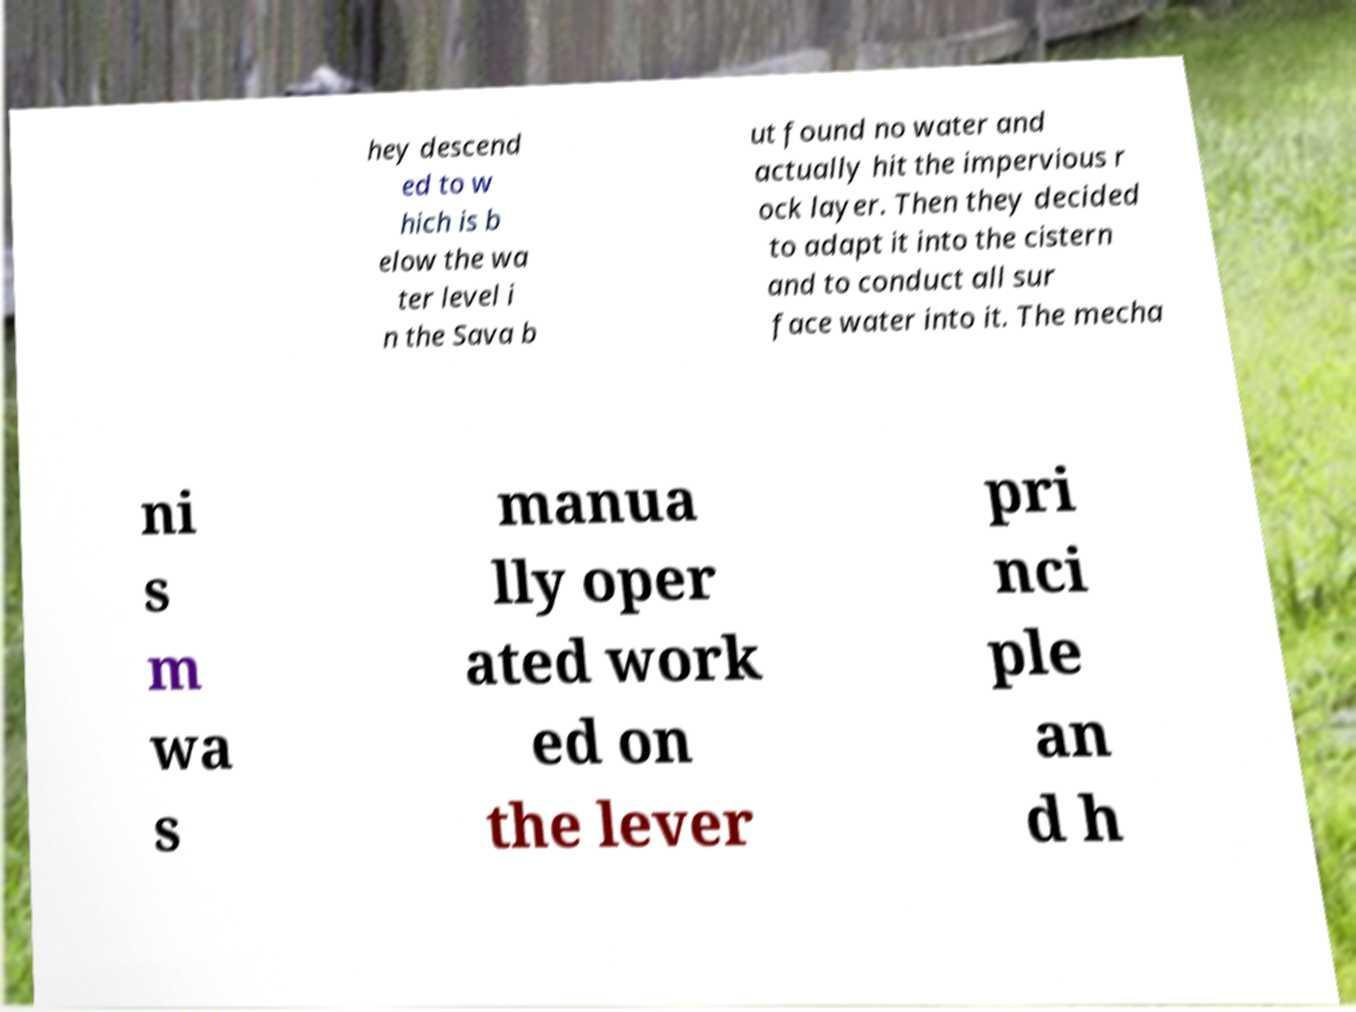Could you assist in decoding the text presented in this image and type it out clearly? hey descend ed to w hich is b elow the wa ter level i n the Sava b ut found no water and actually hit the impervious r ock layer. Then they decided to adapt it into the cistern and to conduct all sur face water into it. The mecha ni s m wa s manua lly oper ated work ed on the lever pri nci ple an d h 